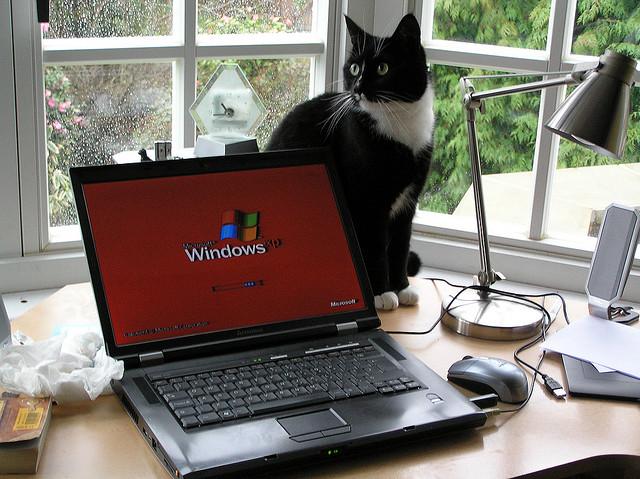Is the cat typing?
Concise answer only. No. What does the screen say?
Keep it brief. Windows. What color is the cat's mittens?
Be succinct. White. 